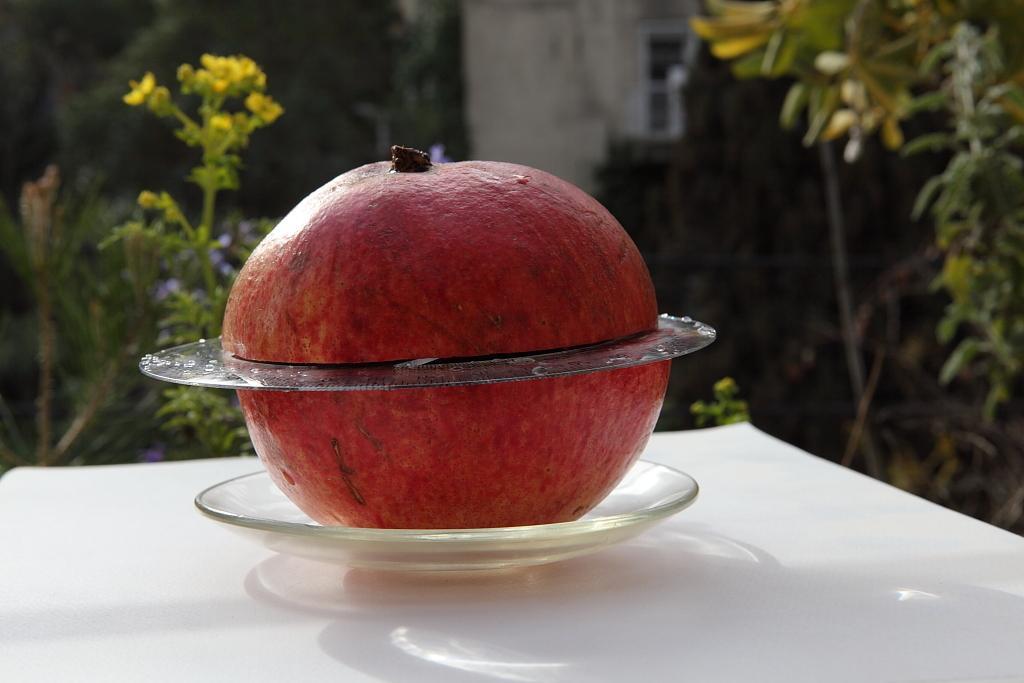Please provide a concise description of this image. In this picture we can see red pomegranate in the small transparent plate, placed on the wooden table top. Behind we can see some plants. 